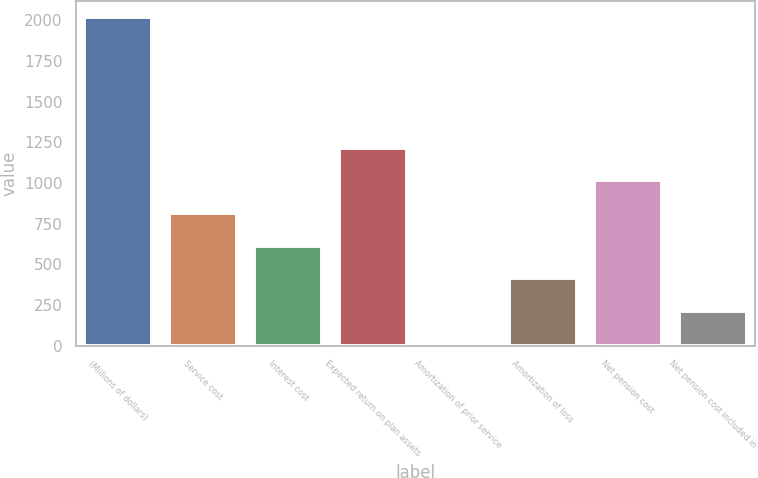<chart> <loc_0><loc_0><loc_500><loc_500><bar_chart><fcel>(Millions of dollars)<fcel>Service cost<fcel>Interest cost<fcel>Expected return on plan assets<fcel>Amortization of prior service<fcel>Amortization of loss<fcel>Net pension cost<fcel>Net pension cost included in<nl><fcel>2019<fcel>815.4<fcel>614.8<fcel>1216.6<fcel>13<fcel>414.2<fcel>1016<fcel>213.6<nl></chart> 